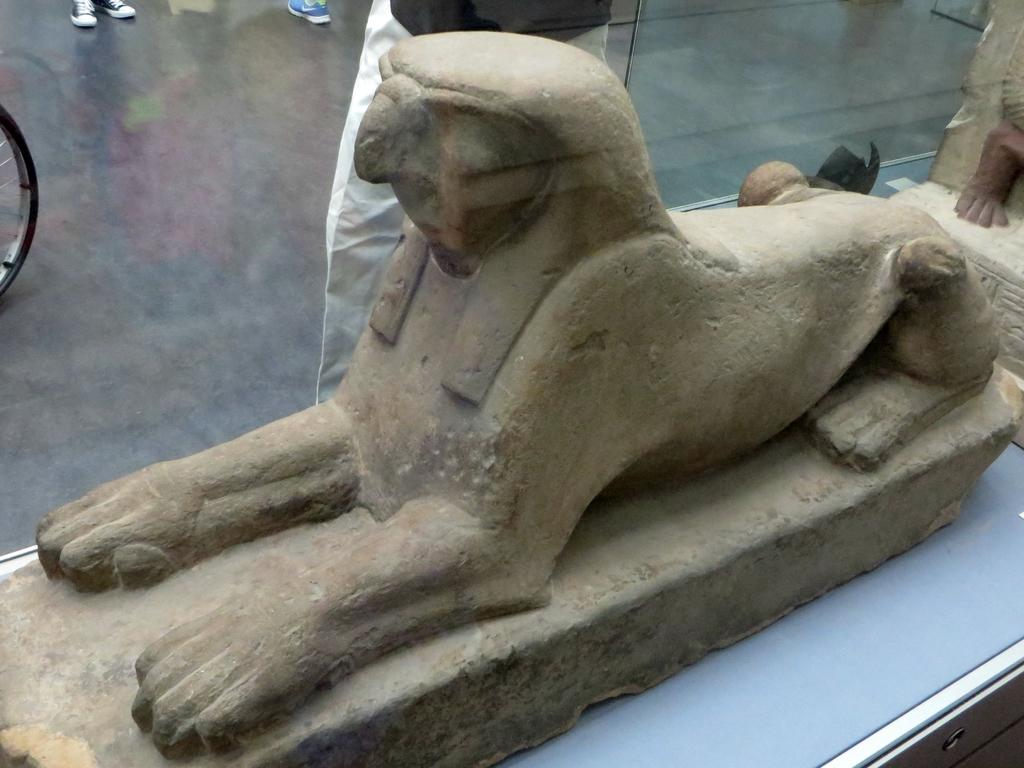What is the main subject in the foreground of the image? There is a stone sculpture inside the glass in the foreground. What can be seen in the background of the image? There is a person and a tyre of a cycle in the background. Are there any other objects visible in the background? Yes, there are shoes on the floor in the background. Absurd Question/Answer: What type of vacation is the lawyer planning with the giants in the image? There is no reference to a vacation, a lawyer, or giants in the image, so it's not possible to determine any vacation plans or the presence of giants. What type of shoes are the giants wearing in the image? There is no reference to giants in the image, so it's not possible to determine what type of shoes they might be wearing. 